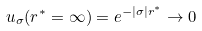Convert formula to latex. <formula><loc_0><loc_0><loc_500><loc_500>u _ { \sigma } ( r ^ { * } = \infty ) = e ^ { - | \sigma | r ^ { * } } \rightarrow 0</formula> 